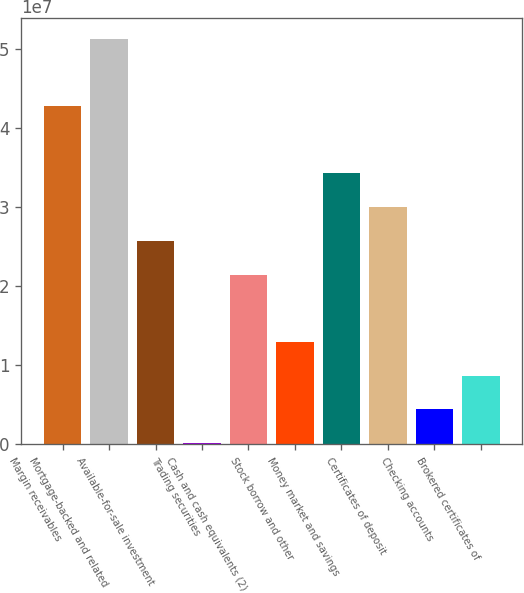<chart> <loc_0><loc_0><loc_500><loc_500><bar_chart><fcel>Margin receivables<fcel>Mortgage-backed and related<fcel>Available-for-sale investment<fcel>Trading securities<fcel>Cash and cash equivalents (2)<fcel>Stock borrow and other<fcel>Money market and savings<fcel>Certificates of deposit<fcel>Checking accounts<fcel>Brokered certificates of<nl><fcel>4.28088e+07<fcel>5.13441e+07<fcel>2.57383e+07<fcel>132454<fcel>2.14706e+07<fcel>1.29354e+07<fcel>3.42735e+07<fcel>3.00059e+07<fcel>4.40009e+06<fcel>8.66773e+06<nl></chart> 